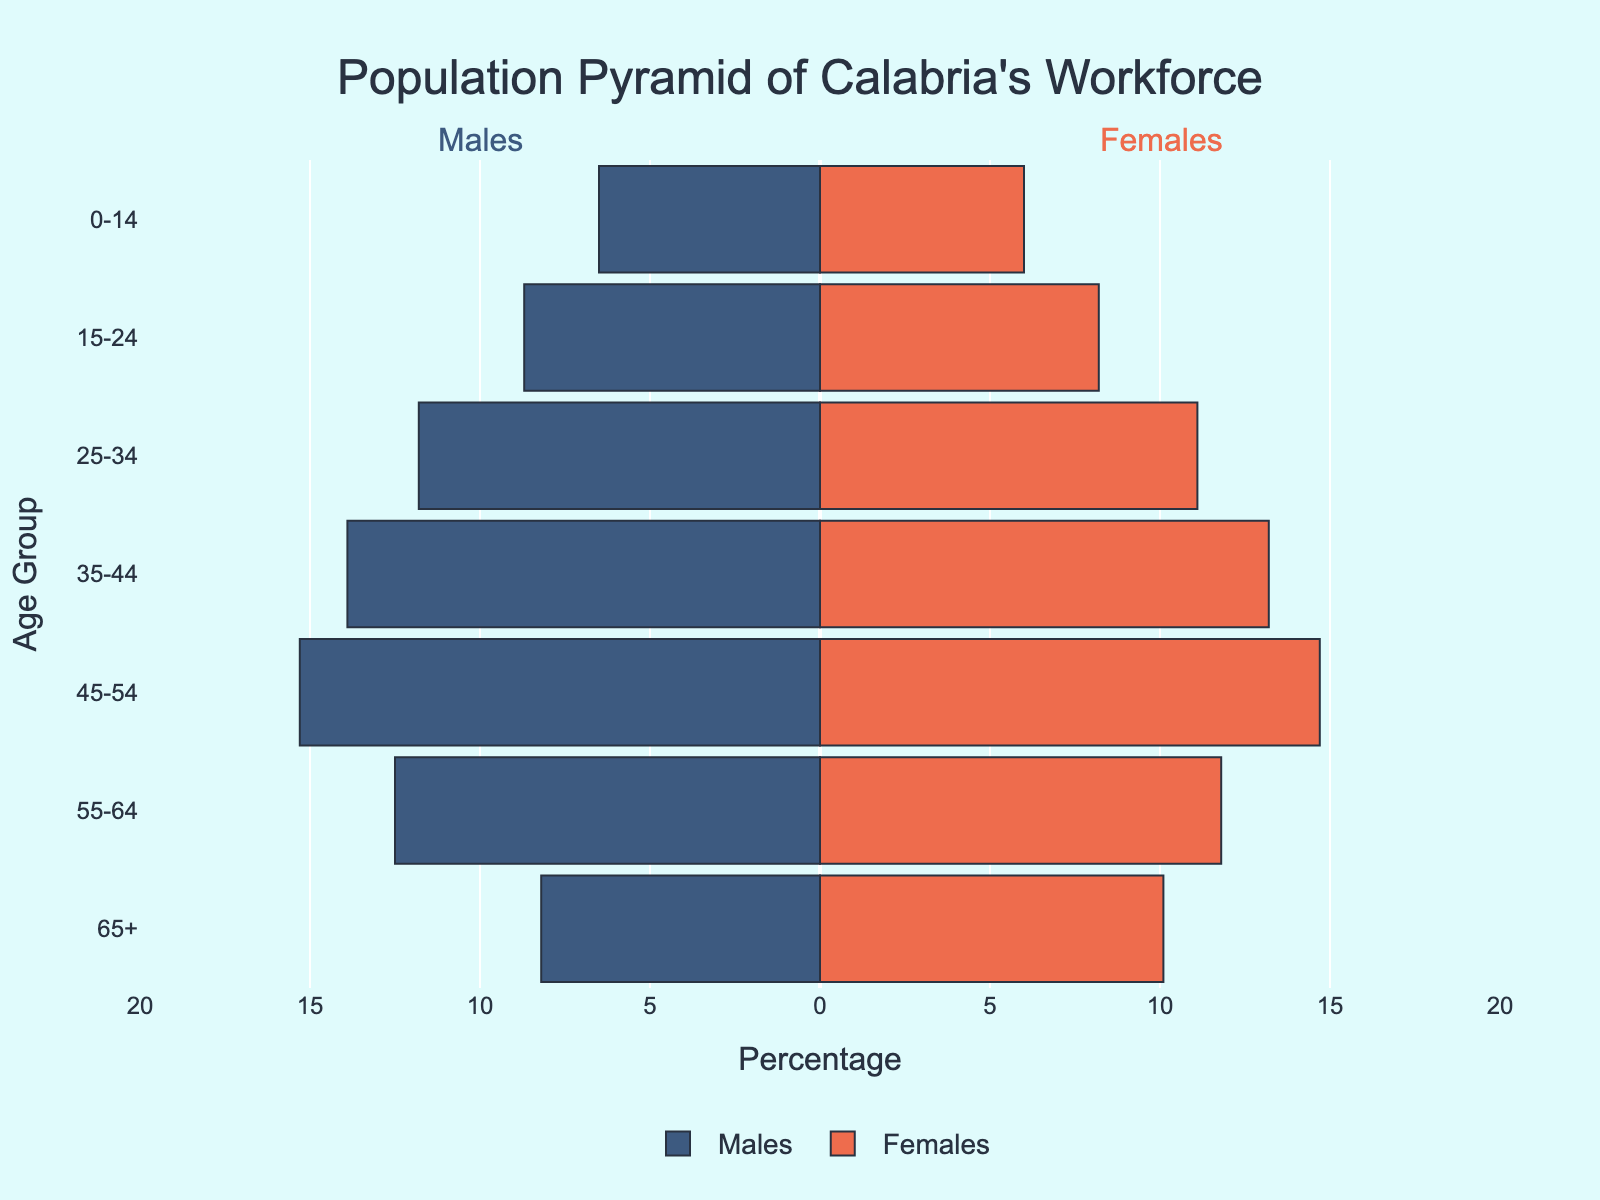What is the title of the plot? The title of the plot is located at the top and it reads "Population Pyramid of Calabria's Workforce".
Answer: Population Pyramid of Calabria's Workforce Which age group has the highest percentage of males in the workforce? By looking at the longest leftward bar, the age group 45-54 has the highest percentage of males.
Answer: 45-54 How does the percentage of females in the age group 25-34 compare to that of males in the same age group? The percentage of females in the age group 25-34 is indicated by a rightward bar of 11.1%, whereas the percentage of males in the same age group is indicated by a leftward bar of 11.8%.
Answer: Females: 11.1%, Males: 11.8% What is the total percentage of the workforce aged 55-64 for both genders combined? The percentage for males aged 55-64 is 12.5% and for females, it's 11.8%. Adding them together, we get 12.5% + 11.8% = 24.3%.
Answer: 24.3% Which gender has a higher percentage in the age group 65+? The percentage of females in the age group 65+ is 10.1%, and for males, it is 8.2%. Therefore, females have a higher percentage in this age group.
Answer: Females How does the workforce distribution for the age group 15-24 compare between genders? The percentage of males in the age group 15-24 is 8.7% while for females it is 8.2%.
Answer: Males: 8.7%, Females: 8.2% What is the difference in the workforce percentage between males and females in the age group 45-54? The percentage of males in the age group 45-54 is 15.3%, and for females, it is 14.7%, so the difference is 15.3% - 14.7% = 0.6%.
Answer: 0.6% Which age group shows the least gender disparity in workforce percentage? By observing all the bars, the age group 0-14 has the least disparity, with 6.5% for males and 6.0% for females, a difference of 0.5%.
Answer: 0-14 What is the average percentage of the workforce for females across all age groups? Summing up the percentages for females: 10.1 + 11.8 + 14.7 + 13.2 + 11.1 + 8.2 + 6.0 = 75.1%. There are 7 age groups, so the average is 75.1 / 7 ≈ 10.73%.
Answer: 10.73% 